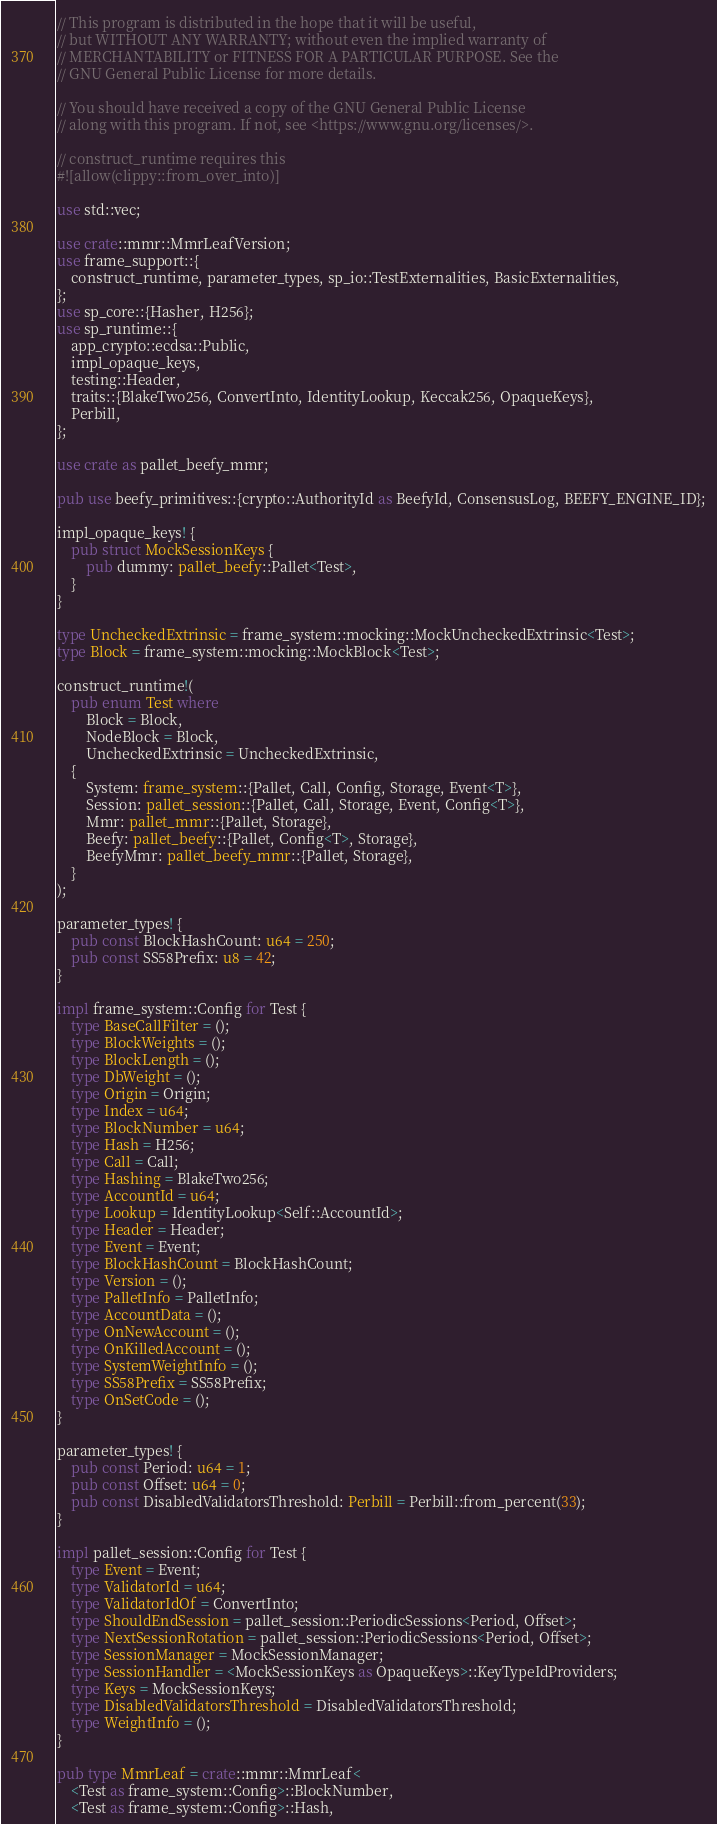<code> <loc_0><loc_0><loc_500><loc_500><_Rust_>
// This program is distributed in the hope that it will be useful,
// but WITHOUT ANY WARRANTY; without even the implied warranty of
// MERCHANTABILITY or FITNESS FOR A PARTICULAR PURPOSE. See the
// GNU General Public License for more details.

// You should have received a copy of the GNU General Public License
// along with this program. If not, see <https://www.gnu.org/licenses/>.

// construct_runtime requires this
#![allow(clippy::from_over_into)]

use std::vec;

use crate::mmr::MmrLeafVersion;
use frame_support::{
    construct_runtime, parameter_types, sp_io::TestExternalities, BasicExternalities,
};
use sp_core::{Hasher, H256};
use sp_runtime::{
    app_crypto::ecdsa::Public,
    impl_opaque_keys,
    testing::Header,
    traits::{BlakeTwo256, ConvertInto, IdentityLookup, Keccak256, OpaqueKeys},
    Perbill,
};

use crate as pallet_beefy_mmr;

pub use beefy_primitives::{crypto::AuthorityId as BeefyId, ConsensusLog, BEEFY_ENGINE_ID};

impl_opaque_keys! {
    pub struct MockSessionKeys {
        pub dummy: pallet_beefy::Pallet<Test>,
    }
}

type UncheckedExtrinsic = frame_system::mocking::MockUncheckedExtrinsic<Test>;
type Block = frame_system::mocking::MockBlock<Test>;

construct_runtime!(
    pub enum Test where
        Block = Block,
        NodeBlock = Block,
        UncheckedExtrinsic = UncheckedExtrinsic,
    {
        System: frame_system::{Pallet, Call, Config, Storage, Event<T>},
        Session: pallet_session::{Pallet, Call, Storage, Event, Config<T>},
        Mmr: pallet_mmr::{Pallet, Storage},
        Beefy: pallet_beefy::{Pallet, Config<T>, Storage},
        BeefyMmr: pallet_beefy_mmr::{Pallet, Storage},
    }
);

parameter_types! {
    pub const BlockHashCount: u64 = 250;
    pub const SS58Prefix: u8 = 42;
}

impl frame_system::Config for Test {
    type BaseCallFilter = ();
    type BlockWeights = ();
    type BlockLength = ();
    type DbWeight = ();
    type Origin = Origin;
    type Index = u64;
    type BlockNumber = u64;
    type Hash = H256;
    type Call = Call;
    type Hashing = BlakeTwo256;
    type AccountId = u64;
    type Lookup = IdentityLookup<Self::AccountId>;
    type Header = Header;
    type Event = Event;
    type BlockHashCount = BlockHashCount;
    type Version = ();
    type PalletInfo = PalletInfo;
    type AccountData = ();
    type OnNewAccount = ();
    type OnKilledAccount = ();
    type SystemWeightInfo = ();
    type SS58Prefix = SS58Prefix;
    type OnSetCode = ();
}

parameter_types! {
    pub const Period: u64 = 1;
    pub const Offset: u64 = 0;
    pub const DisabledValidatorsThreshold: Perbill = Perbill::from_percent(33);
}

impl pallet_session::Config for Test {
    type Event = Event;
    type ValidatorId = u64;
    type ValidatorIdOf = ConvertInto;
    type ShouldEndSession = pallet_session::PeriodicSessions<Period, Offset>;
    type NextSessionRotation = pallet_session::PeriodicSessions<Period, Offset>;
    type SessionManager = MockSessionManager;
    type SessionHandler = <MockSessionKeys as OpaqueKeys>::KeyTypeIdProviders;
    type Keys = MockSessionKeys;
    type DisabledValidatorsThreshold = DisabledValidatorsThreshold;
    type WeightInfo = ();
}

pub type MmrLeaf = crate::mmr::MmrLeaf<
    <Test as frame_system::Config>::BlockNumber,
    <Test as frame_system::Config>::Hash,</code> 